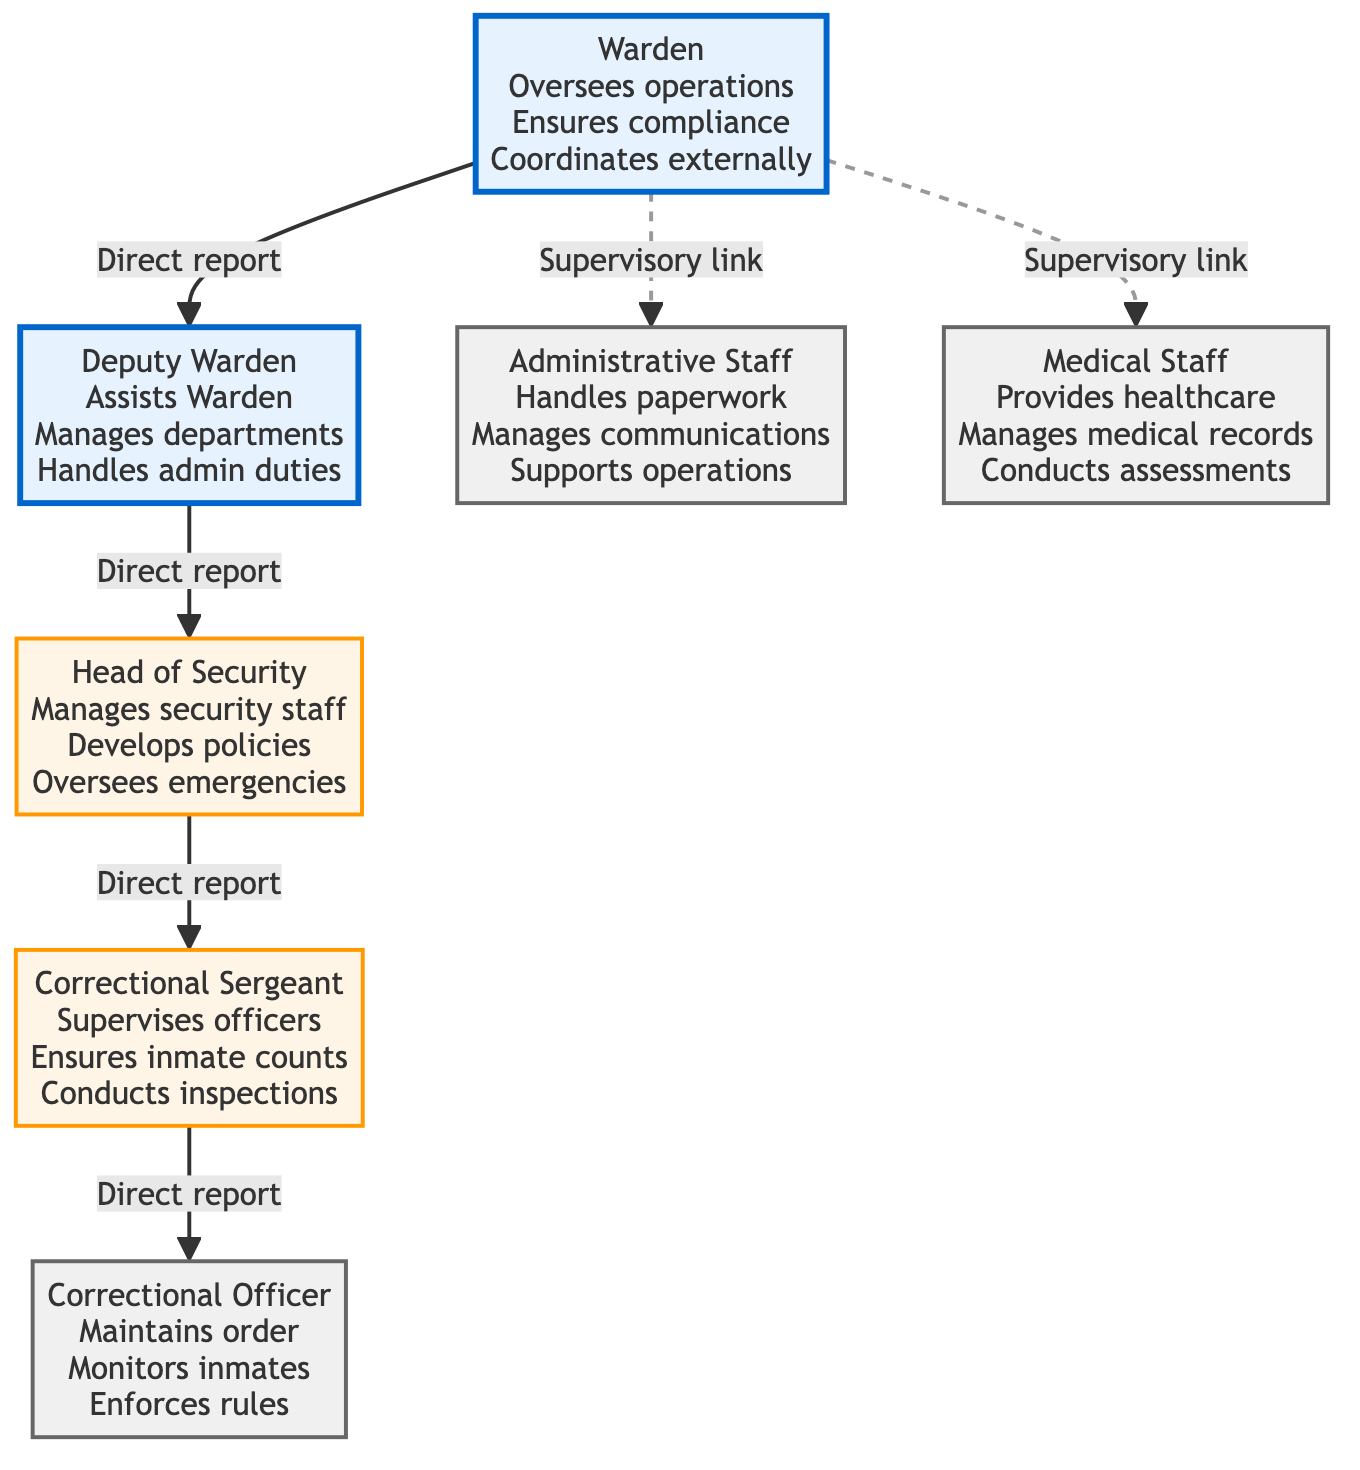What is the highest position in the chain of command? The diagram indicates that the highest position is the Warden. The Warden is depicted at the top of the diagram, overseeing all operations within the facility.
Answer: Warden How many direct reports does the Warden have? By examining the diagram, the Warden has two direct reports: the Deputy Warden and the Head of Security. Each of these roles is linked directly to the Warden.
Answer: 2 Who supervises the Correctional Officers? The diagram shows that the Correctional Sergeant supervises the Correctional Officers. The Correctional Sergeant is directly connected to Correctional Officers within the hierarchy.
Answer: Correctional Sergeant What role is responsible for managing medical records? The diagram highlights that the Medical Staff is responsible for managing medical records, as indicated by the description under the Medical Staff node.
Answer: Medical Staff Is the Administrative Staff connected directly to the Deputy Warden? The diagram indicates that the Administrative Staff is not directly connected to the Deputy Warden; instead, the relationship is a supervisory link to the Warden. Thus, there is no direct line connecting the Administrative Staff to the Deputy Warden.
Answer: No Which position is responsible for handling emergencies? According to the diagram, the Head of Security is responsible for overseeing emergencies. This responsibility is specifically outlined in the description associated with the Head of Security node.
Answer: Head of Security What is the relationship between the Correctional Sergeant and the Head of Security? The diagram illustrates that there is a direct reporting relationship from the Correctional Sergeant to the Head of Security. This means that the Correctional Sergeant reports directly to the Head of Security within the chain of command.
Answer: Direct report What type of link connects the Warden to the Administrative Staff and Medical Staff? The relationship linking the Warden to both the Administrative Staff and Medical Staff is shown as a supervisory link, represented by a dashed line in the diagram. This indicates an indirect supervisory relationship rather than a direct report.
Answer: Supervisory link How many positions fall under the Head of Security? The diagram indicates that the Head of Security has one position directly under it, which is the Correctional Sergeant. The line connecting these two roles shows this direct relationship in the hierarchy.
Answer: 1 